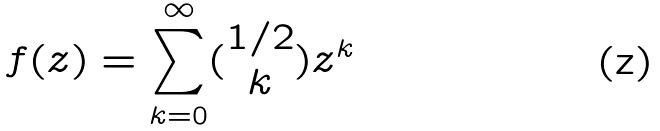Convert formula to latex. <formula><loc_0><loc_0><loc_500><loc_500>f ( z ) = \sum _ { k = 0 } ^ { \infty } ( \begin{matrix} 1 / 2 \\ k \end{matrix} ) z ^ { k }</formula> 